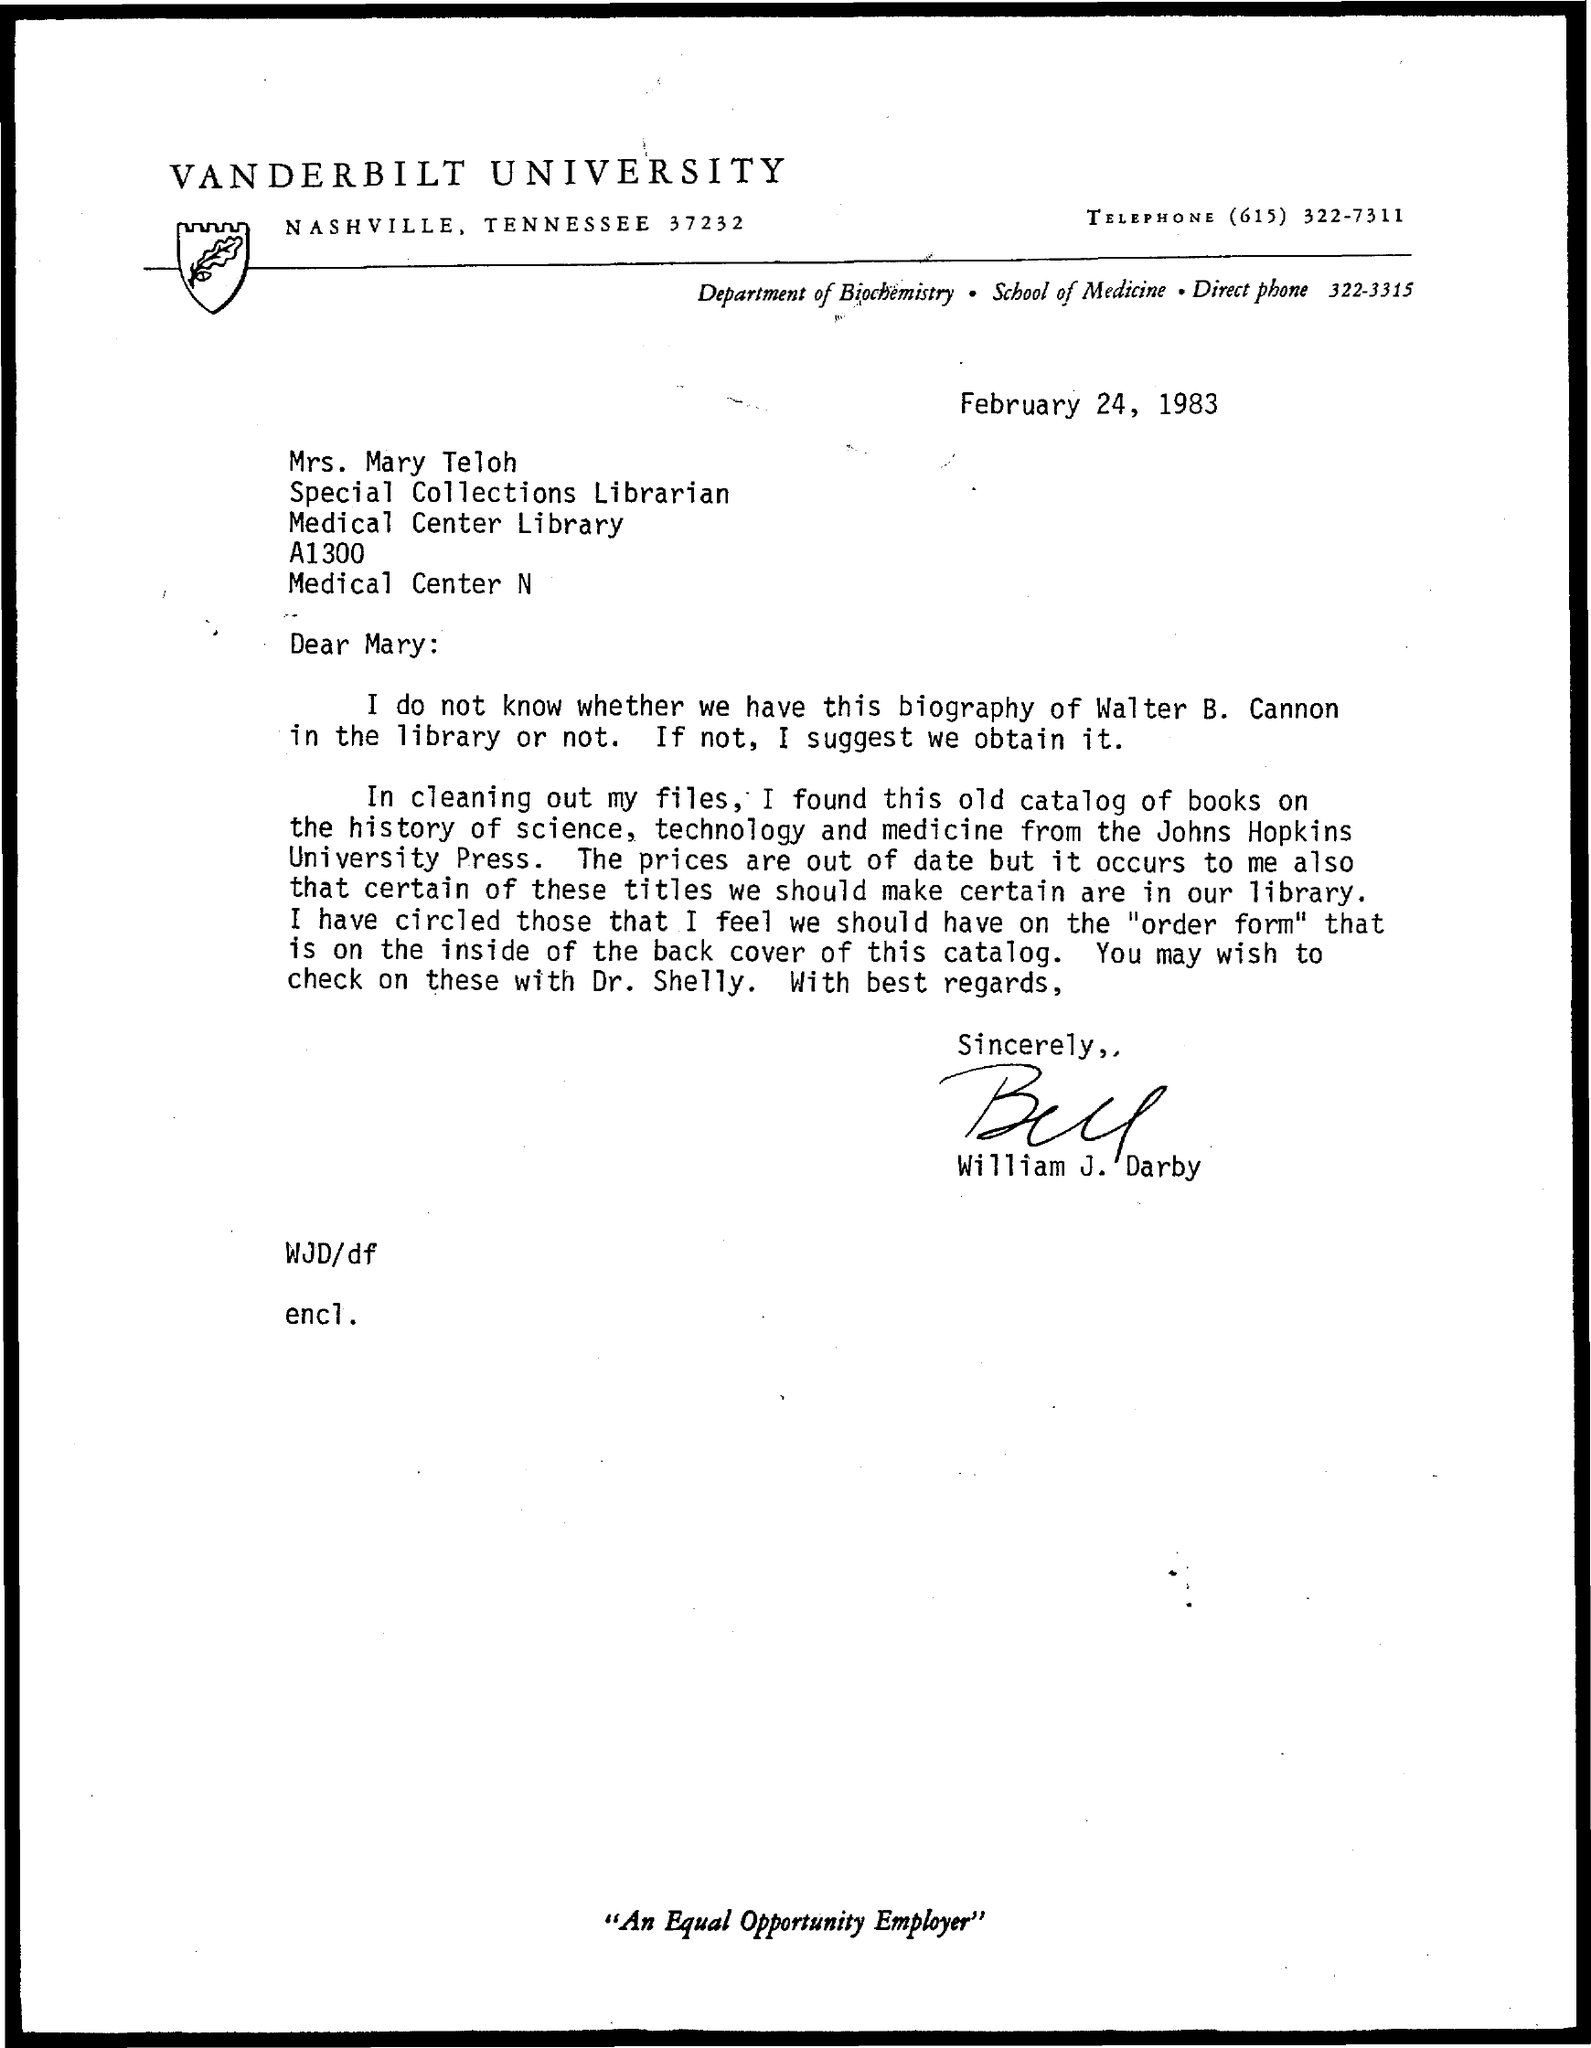List a handful of essential elements in this visual. The letter has been signed by William J. Darby. The letterhead mentions Vanderbilt University. The date mentioned in this letter is February 24, 1983. 